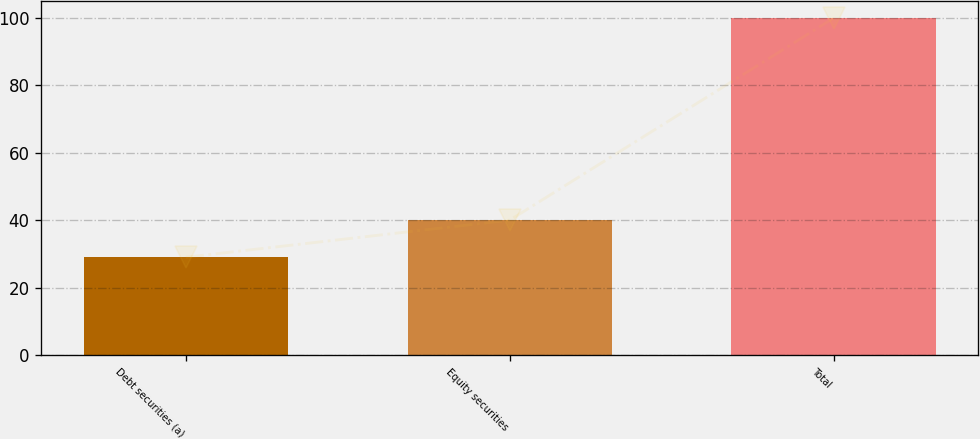Convert chart to OTSL. <chart><loc_0><loc_0><loc_500><loc_500><bar_chart><fcel>Debt securities (a)<fcel>Equity securities<fcel>Total<nl><fcel>29<fcel>40<fcel>100<nl></chart> 